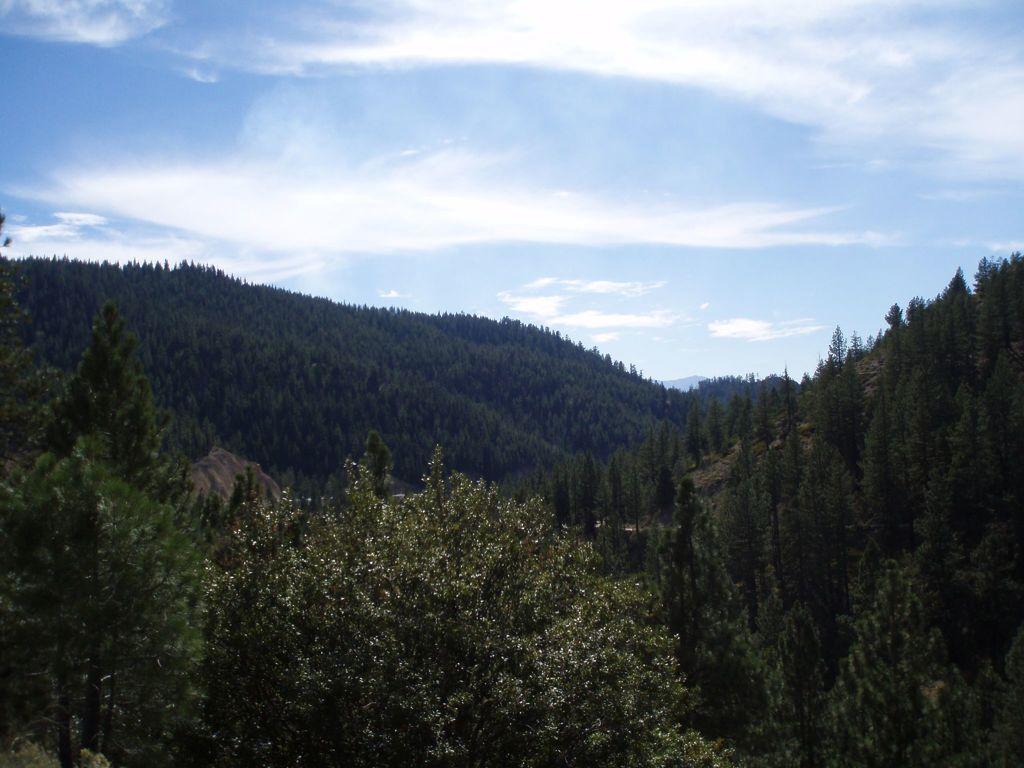Could you give a brief overview of what you see in this image? In this picture I can observe some trees. In the background there are hills and some clouds in the sky. 